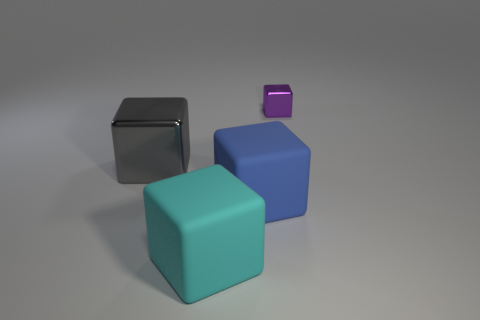Add 1 small purple matte cylinders. How many objects exist? 5 Subtract all tiny purple cubes. How many cubes are left? 3 Subtract all cyan blocks. How many blocks are left? 3 Subtract 0 red blocks. How many objects are left? 4 Subtract 1 cubes. How many cubes are left? 3 Subtract all brown blocks. Subtract all cyan balls. How many blocks are left? 4 Subtract all gray cubes. Subtract all large matte objects. How many objects are left? 1 Add 2 purple cubes. How many purple cubes are left? 3 Add 2 metallic things. How many metallic things exist? 4 